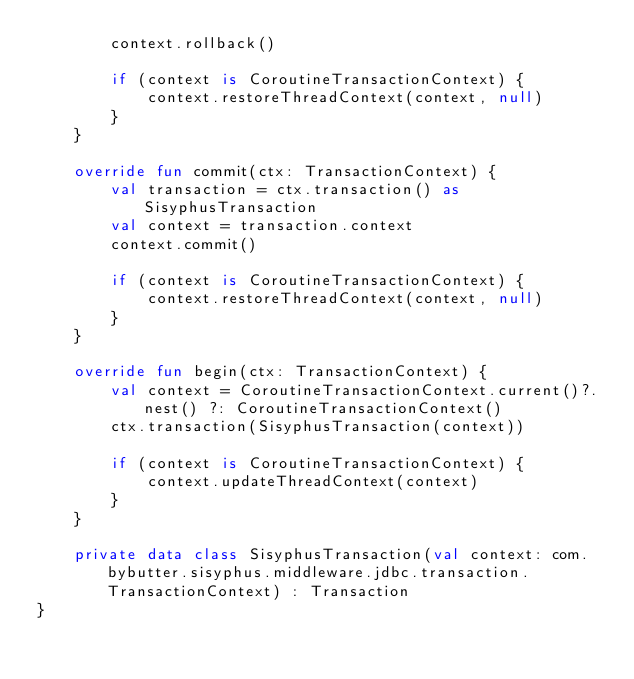Convert code to text. <code><loc_0><loc_0><loc_500><loc_500><_Kotlin_>        context.rollback()

        if (context is CoroutineTransactionContext) {
            context.restoreThreadContext(context, null)
        }
    }

    override fun commit(ctx: TransactionContext) {
        val transaction = ctx.transaction() as SisyphusTransaction
        val context = transaction.context
        context.commit()

        if (context is CoroutineTransactionContext) {
            context.restoreThreadContext(context, null)
        }
    }

    override fun begin(ctx: TransactionContext) {
        val context = CoroutineTransactionContext.current()?.nest() ?: CoroutineTransactionContext()
        ctx.transaction(SisyphusTransaction(context))

        if (context is CoroutineTransactionContext) {
            context.updateThreadContext(context)
        }
    }

    private data class SisyphusTransaction(val context: com.bybutter.sisyphus.middleware.jdbc.transaction.TransactionContext) : Transaction
}
</code> 